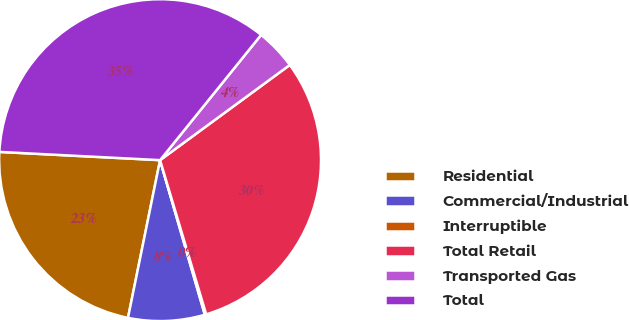Convert chart to OTSL. <chart><loc_0><loc_0><loc_500><loc_500><pie_chart><fcel>Residential<fcel>Commercial/Industrial<fcel>Interruptible<fcel>Total Retail<fcel>Transported Gas<fcel>Total<nl><fcel>22.62%<fcel>7.68%<fcel>0.14%<fcel>30.45%<fcel>4.12%<fcel>34.99%<nl></chart> 